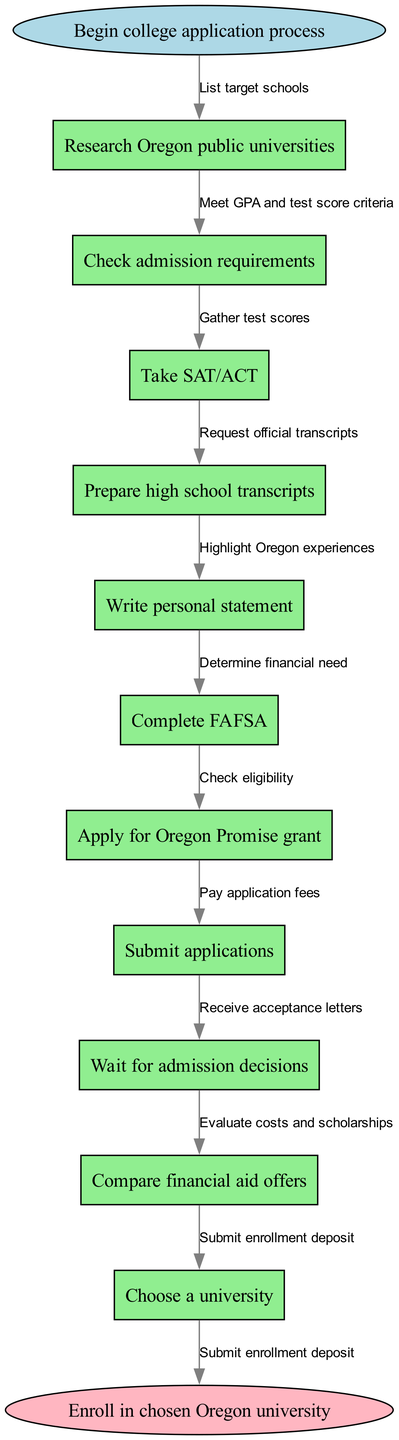What is the first step in the college application process? The diagram starts with the node labeled "Begin college application process," which indicates the initial step in the flowchart.
Answer: Begin college application process How many nodes are there in the diagram? By counting the listed nodes under the "nodes" section in the data, there are 11 nodes in total: 1 start node, 9 process nodes, and 1 end node.
Answer: 11 What edge connects "Complete FAFSA" to the next node? In the flowchart, the edge leading from "Complete FAFSA" connects to the next node, which is "Apply for Oregon Promise grant." This can be verified by examining the connections mapped between nodes.
Answer: Apply for Oregon Promise grant What should you do after checking admission requirements? The flowchart indicates that the next step after "Check admission requirements" is "Take SAT/ACT." This progression can be followed through the directional edges connecting the nodes.
Answer: Take SAT/ACT What is the purpose of submitting the FAFSA? The diagram suggests that "Complete FAFSA" is tied to determining financial need, which is essential for assessing financial aid eligibility. This can be inferred based on the logical flow from that step to the next.
Answer: Determine financial need What is the last step in the application process? The flowchart concludes with the node labeled "Enroll in chosen Oregon university," marking it as the final action in the process.
Answer: Enroll in chosen Oregon university How many edges connect the nodes? Each transition between the nodes, including from start to end, can be counted and confirms there are 10 edges that connect the nodes in the flowchart.
Answer: 10 Which step immediately follows writing a personal statement? According to the flowchart, after "Write personal statement," the next step is to "Complete FAFSA," as reflected in the sequential arrangement of the nodes.
Answer: Complete FAFSA What do you receive after submitting applications? The next step after "Submit applications" is "Wait for admission decisions," signifying the expected outcome of that action as denoted in the diagram.
Answer: Wait for admission decisions 